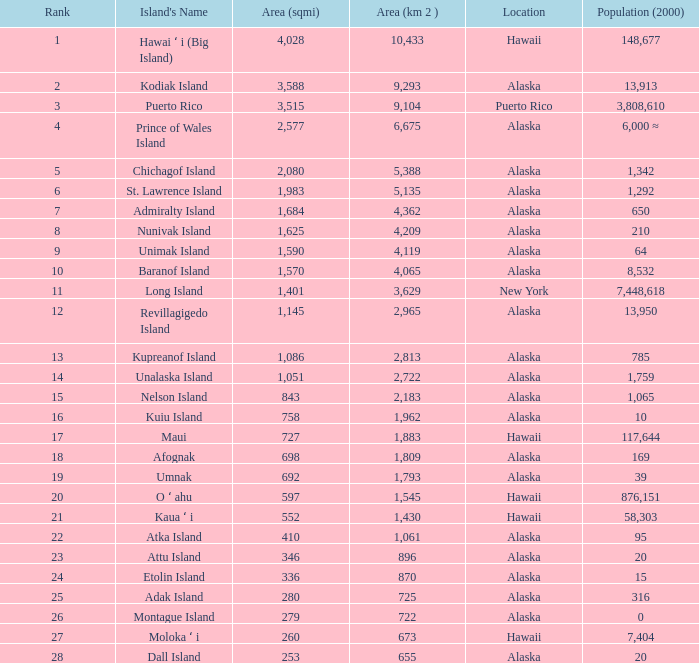What is the largest position with 2,080 area? 5.0. 